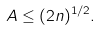Convert formula to latex. <formula><loc_0><loc_0><loc_500><loc_500>A \leq ( 2 n ) ^ { 1 / 2 } .</formula> 